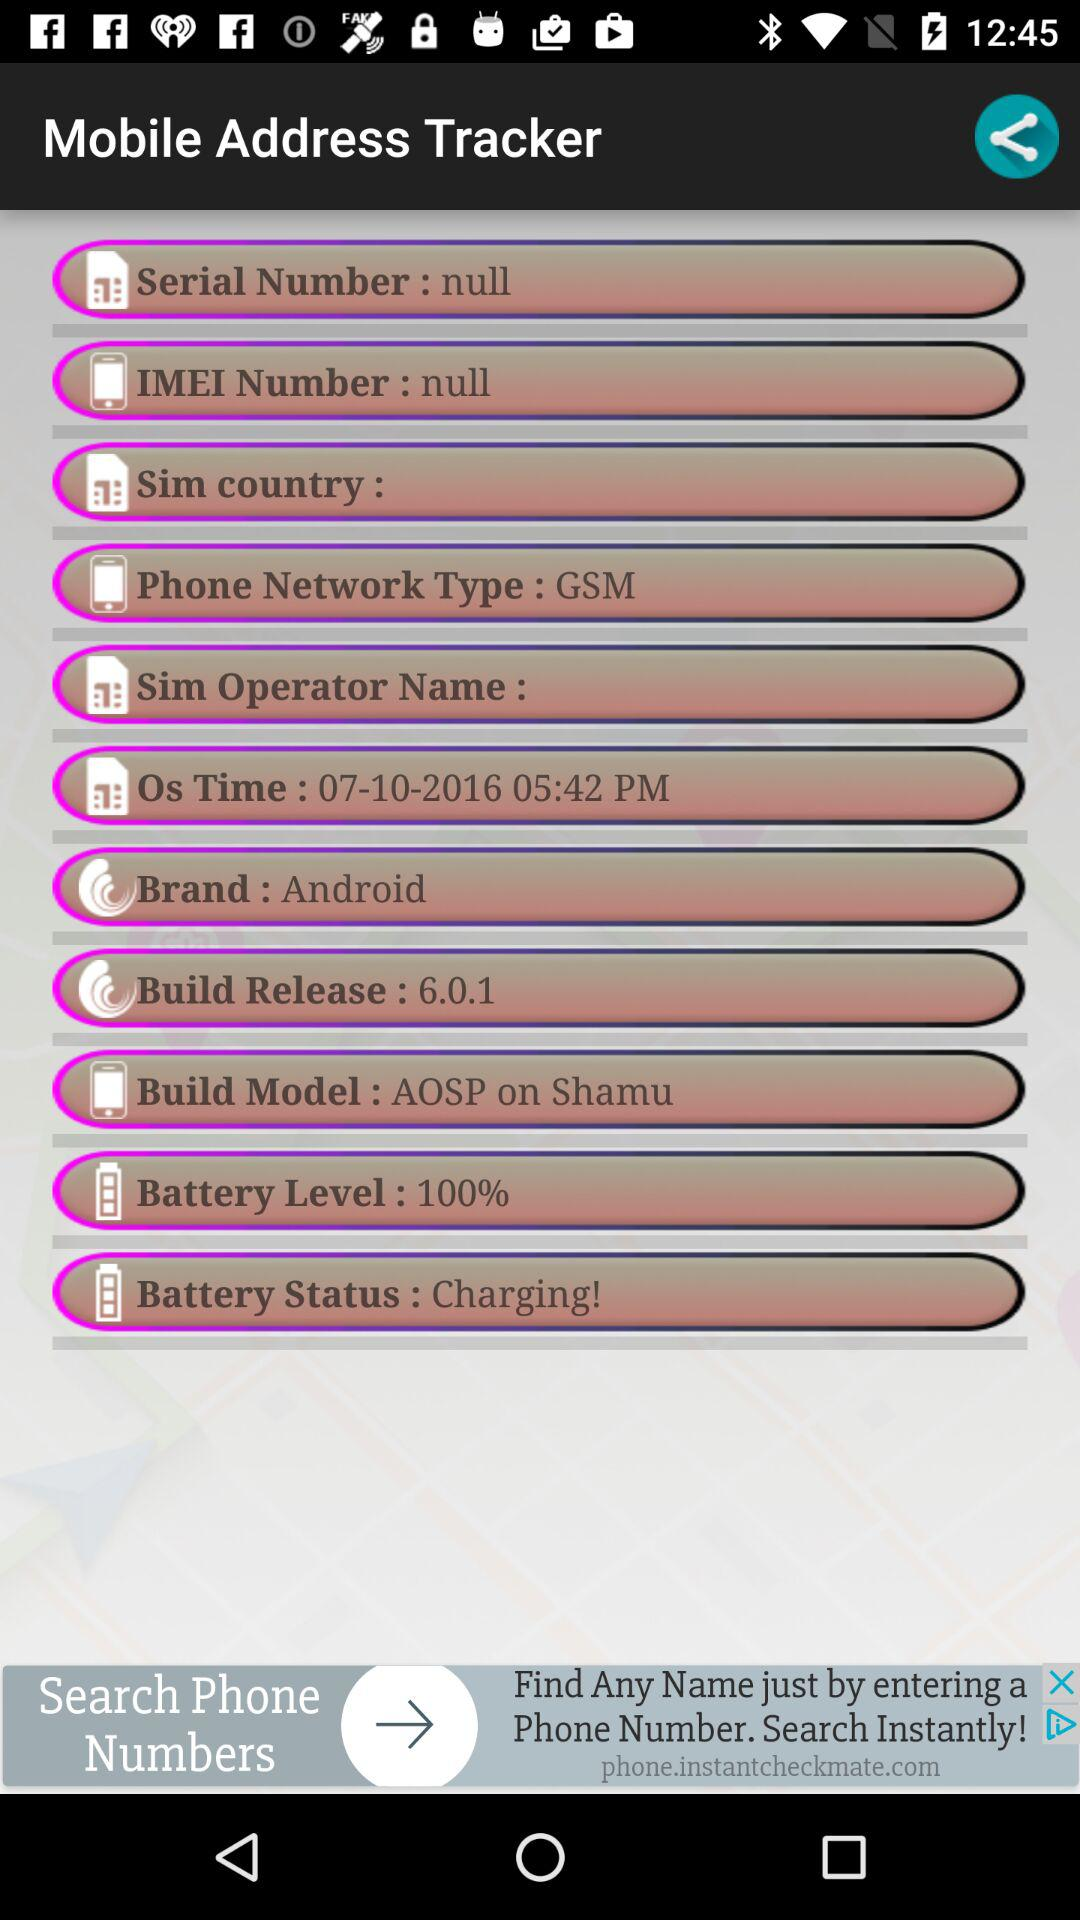What's "Os Time"? "Os Time" is 05:42 PM. 